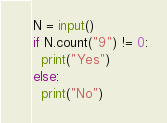Convert code to text. <code><loc_0><loc_0><loc_500><loc_500><_Python_>N = input()
if N.count("9") != 0:
  print("Yes")
else:
  print("No")</code> 